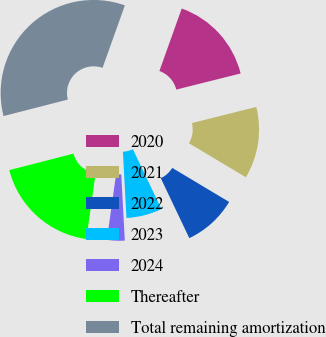Convert chart. <chart><loc_0><loc_0><loc_500><loc_500><pie_chart><fcel>2020<fcel>2021<fcel>2022<fcel>2023<fcel>2024<fcel>Thereafter<fcel>Total remaining amortization<nl><fcel>15.63%<fcel>12.49%<fcel>9.35%<fcel>6.21%<fcel>3.08%<fcel>18.77%<fcel>34.46%<nl></chart> 